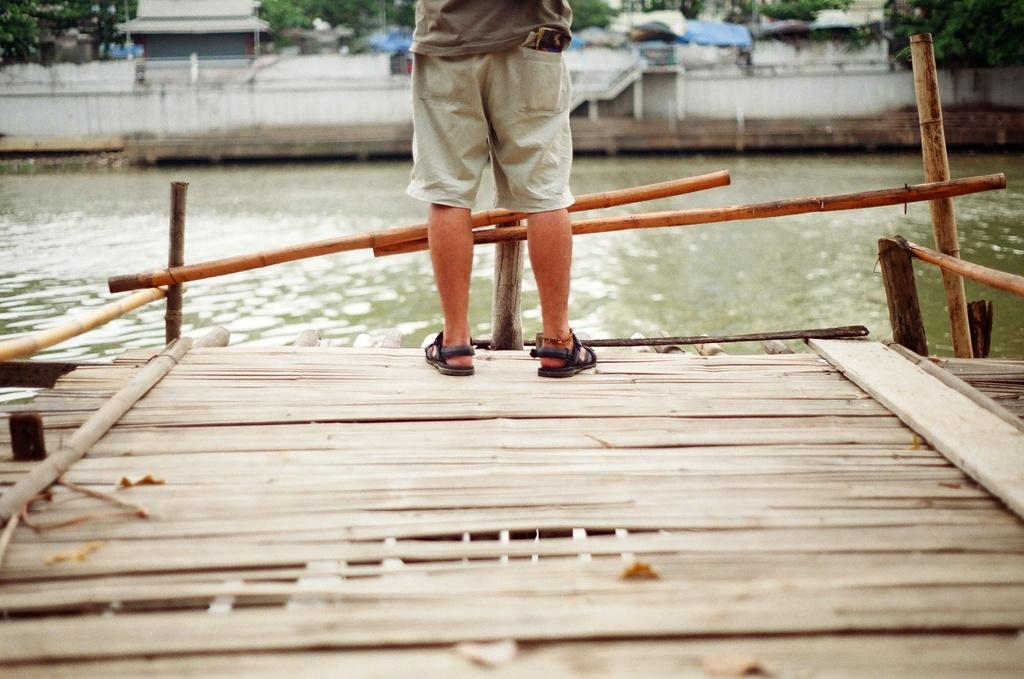What is the person in the image doing? There is a person standing on a platform in the image. What can be seen in the background of the image? Water, sheds, and trees are present in the background of the image. What type of feast is being prepared in the image? There is no indication of a feast or any food preparation in the image. 